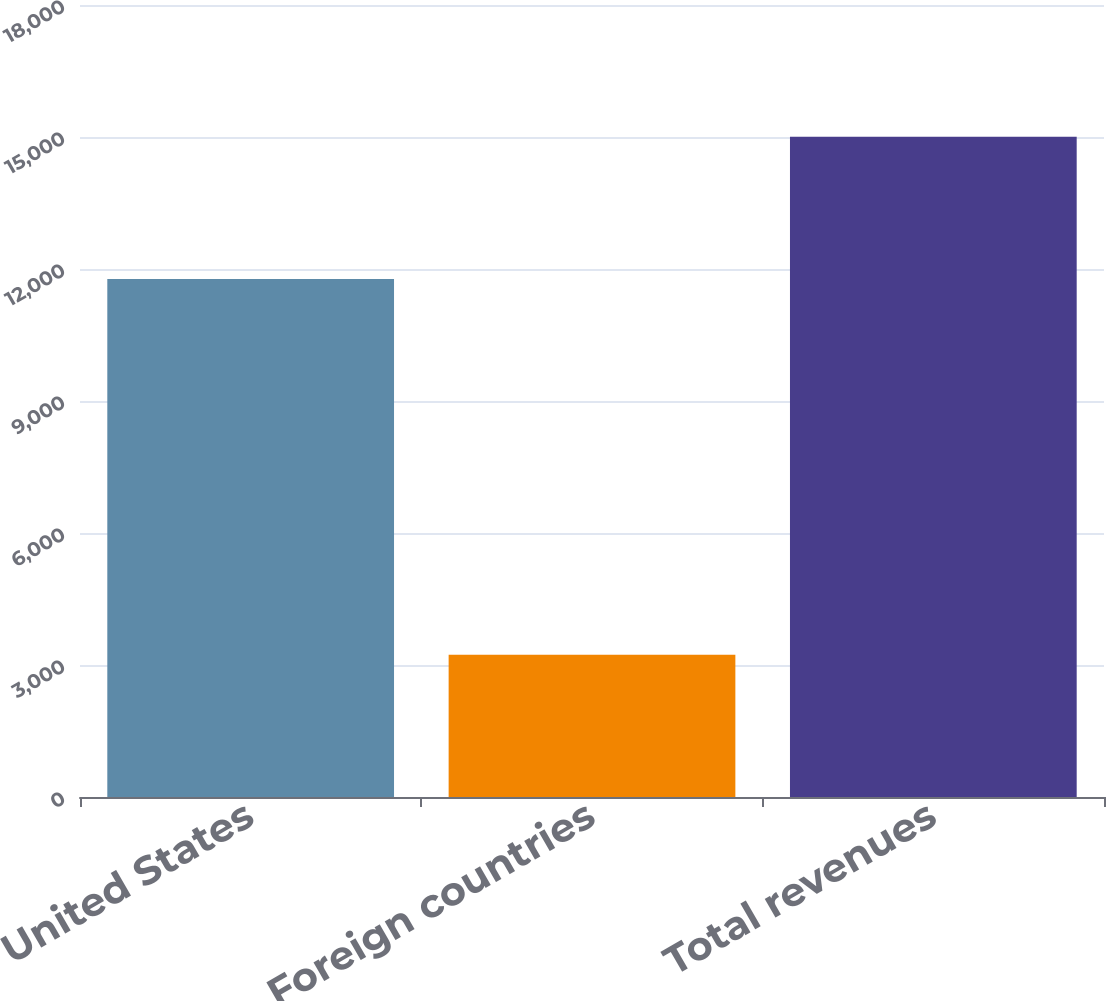<chart> <loc_0><loc_0><loc_500><loc_500><bar_chart><fcel>United States<fcel>Foreign countries<fcel>Total revenues<nl><fcel>11772<fcel>3231<fcel>15003<nl></chart> 